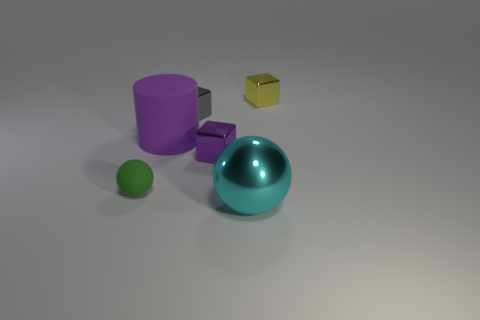What time of day does the lighting in this scene suggest? The scene is lit with a soft, diffuse light, lacking strong shadows or highlights, which gives the impression of an overcast day when the sun's light is scattered by clouds, or an indoor setting with well-diffused artificial lighting. 